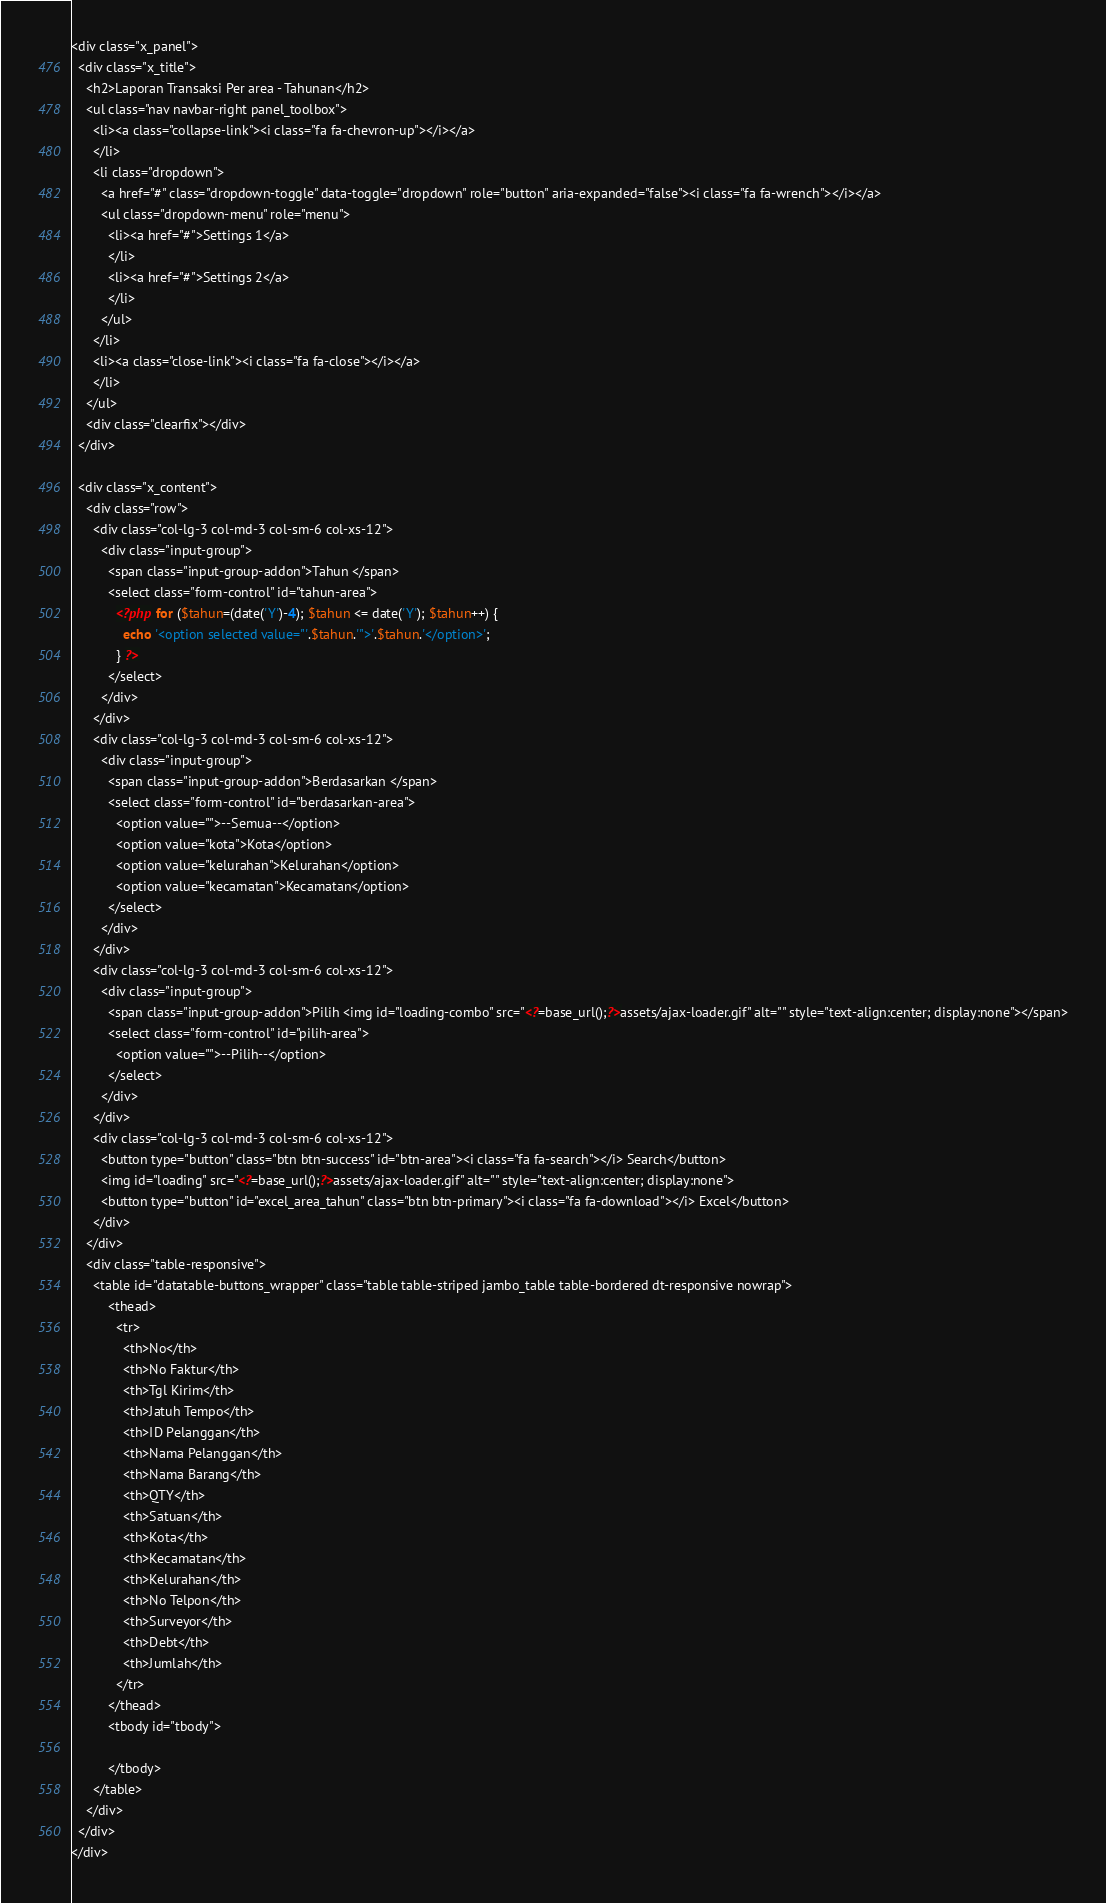Convert code to text. <code><loc_0><loc_0><loc_500><loc_500><_PHP_><div class="x_panel">
  <div class="x_title">
    <h2>Laporan Transaksi Per area - Tahunan</h2>
    <ul class="nav navbar-right panel_toolbox">
      <li><a class="collapse-link"><i class="fa fa-chevron-up"></i></a>
      </li>
      <li class="dropdown">
        <a href="#" class="dropdown-toggle" data-toggle="dropdown" role="button" aria-expanded="false"><i class="fa fa-wrench"></i></a>
        <ul class="dropdown-menu" role="menu">
          <li><a href="#">Settings 1</a>
          </li>
          <li><a href="#">Settings 2</a>
          </li>
        </ul>
      </li>
      <li><a class="close-link"><i class="fa fa-close"></i></a>
      </li>
    </ul>
    <div class="clearfix"></div>
  </div>

  <div class="x_content">
    <div class="row">
      <div class="col-lg-3 col-md-3 col-sm-6 col-xs-12">
        <div class="input-group">
          <span class="input-group-addon">Tahun </span>
          <select class="form-control" id="tahun-area">
            <?php for ($tahun=(date('Y')-4); $tahun <= date('Y'); $tahun++) {
              echo '<option selected value="'.$tahun.'">'.$tahun.'</option>';
            } ?>
          </select>
        </div>
      </div>
      <div class="col-lg-3 col-md-3 col-sm-6 col-xs-12">
        <div class="input-group">
          <span class="input-group-addon">Berdasarkan </span>
          <select class="form-control" id="berdasarkan-area">
            <option value="">--Semua--</option>
            <option value="kota">Kota</option>
            <option value="kelurahan">Kelurahan</option>
            <option value="kecamatan">Kecamatan</option>
          </select>
        </div>
      </div>
      <div class="col-lg-3 col-md-3 col-sm-6 col-xs-12">
        <div class="input-group">
          <span class="input-group-addon">Pilih <img id="loading-combo" src="<?=base_url();?>assets/ajax-loader.gif" alt="" style="text-align:center; display:none"></span>
          <select class="form-control" id="pilih-area">
            <option value="">--Pilih--</option>
          </select>
        </div>
      </div>
      <div class="col-lg-3 col-md-3 col-sm-6 col-xs-12">
        <button type="button" class="btn btn-success" id="btn-area"><i class="fa fa-search"></i> Search</button>
        <img id="loading" src="<?=base_url();?>assets/ajax-loader.gif" alt="" style="text-align:center; display:none">
        <button type="button" id="excel_area_tahun" class="btn btn-primary"><i class="fa fa-download"></i> Excel</button>
      </div>
    </div>
    <div class="table-responsive">
      <table id="datatable-buttons_wrapper" class="table table-striped jambo_table table-bordered dt-responsive nowrap">
          <thead>
            <tr>
              <th>No</th>
              <th>No Faktur</th>
              <th>Tgl Kirim</th>
              <th>Jatuh Tempo</th>
              <th>ID Pelanggan</th>
              <th>Nama Pelanggan</th>
              <th>Nama Barang</th>
              <th>QTY</th>
              <th>Satuan</th>
              <th>Kota</th>
              <th>Kecamatan</th>
              <th>Kelurahan</th>
              <th>No Telpon</th>
              <th>Surveyor</th>
              <th>Debt</th>
              <th>Jumlah</th>
            </tr>
          </thead>
          <tbody id="tbody">

          </tbody>
      </table>
    </div>
  </div>
</div>
</code> 